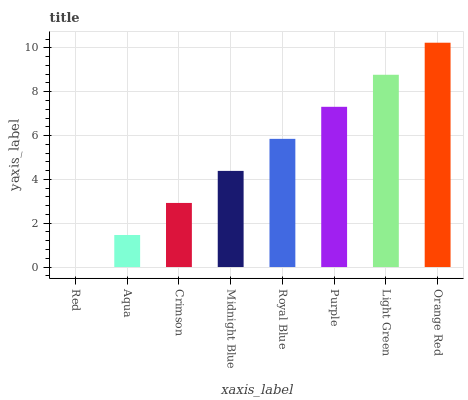Is Aqua the minimum?
Answer yes or no. No. Is Aqua the maximum?
Answer yes or no. No. Is Aqua greater than Red?
Answer yes or no. Yes. Is Red less than Aqua?
Answer yes or no. Yes. Is Red greater than Aqua?
Answer yes or no. No. Is Aqua less than Red?
Answer yes or no. No. Is Royal Blue the high median?
Answer yes or no. Yes. Is Midnight Blue the low median?
Answer yes or no. Yes. Is Red the high median?
Answer yes or no. No. Is Red the low median?
Answer yes or no. No. 